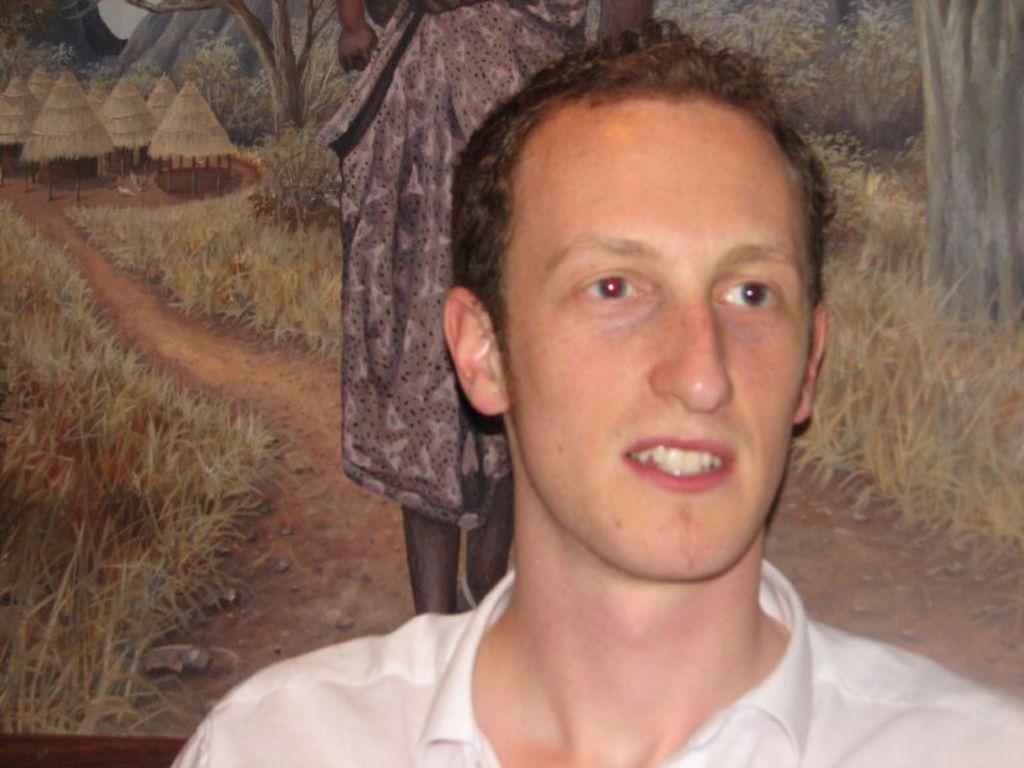In one or two sentences, can you explain what this image depicts? This image consists of a man wearing a white shirt. In the background, it looks like a poster in which there is a woman walking. On the left, we can see the huts and trees. At the bottom, there are rocks and grass on the ground. 